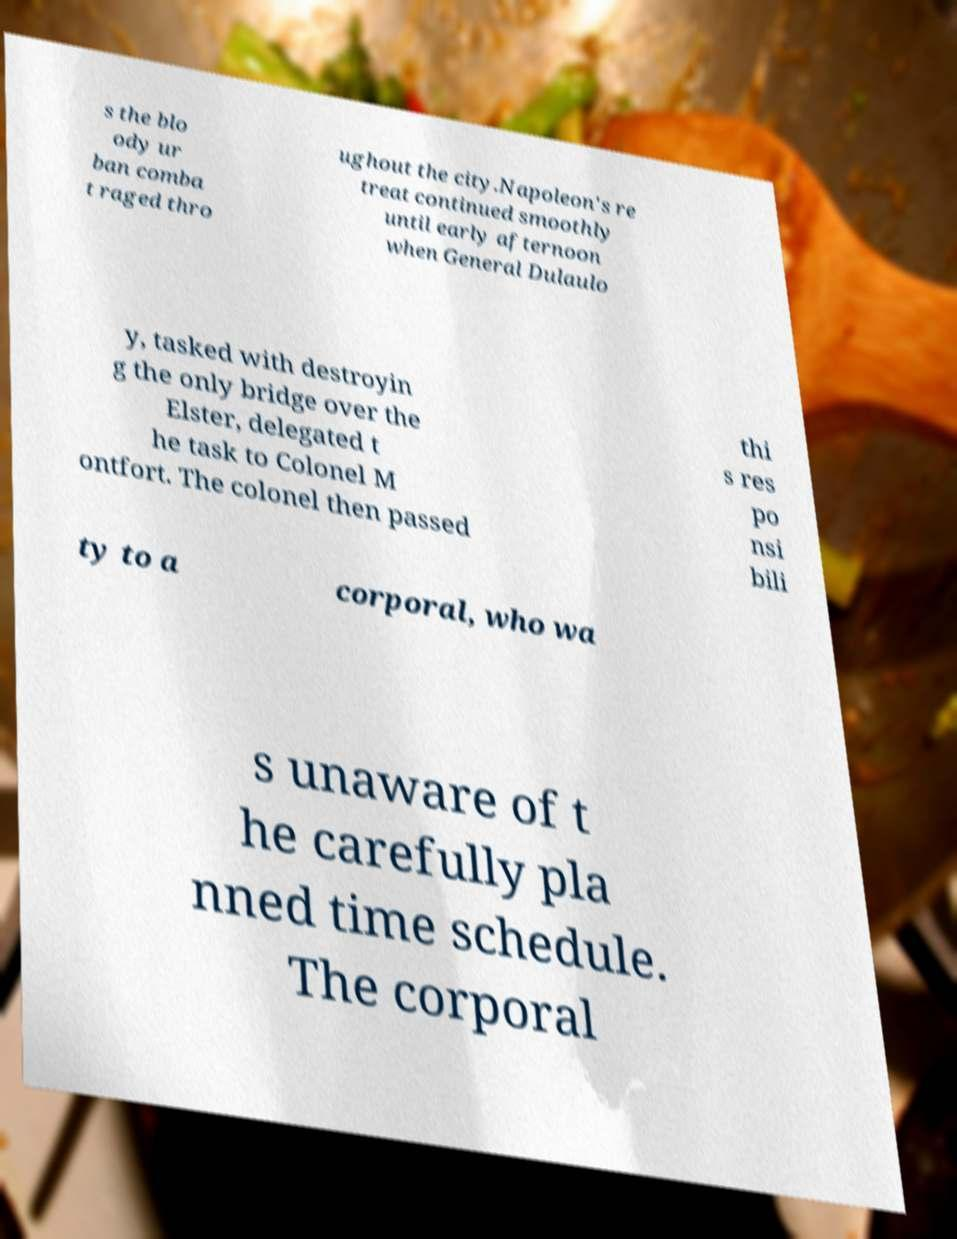Can you accurately transcribe the text from the provided image for me? s the blo ody ur ban comba t raged thro ughout the city.Napoleon's re treat continued smoothly until early afternoon when General Dulaulo y, tasked with destroyin g the only bridge over the Elster, delegated t he task to Colonel M ontfort. The colonel then passed thi s res po nsi bili ty to a corporal, who wa s unaware of t he carefully pla nned time schedule. The corporal 